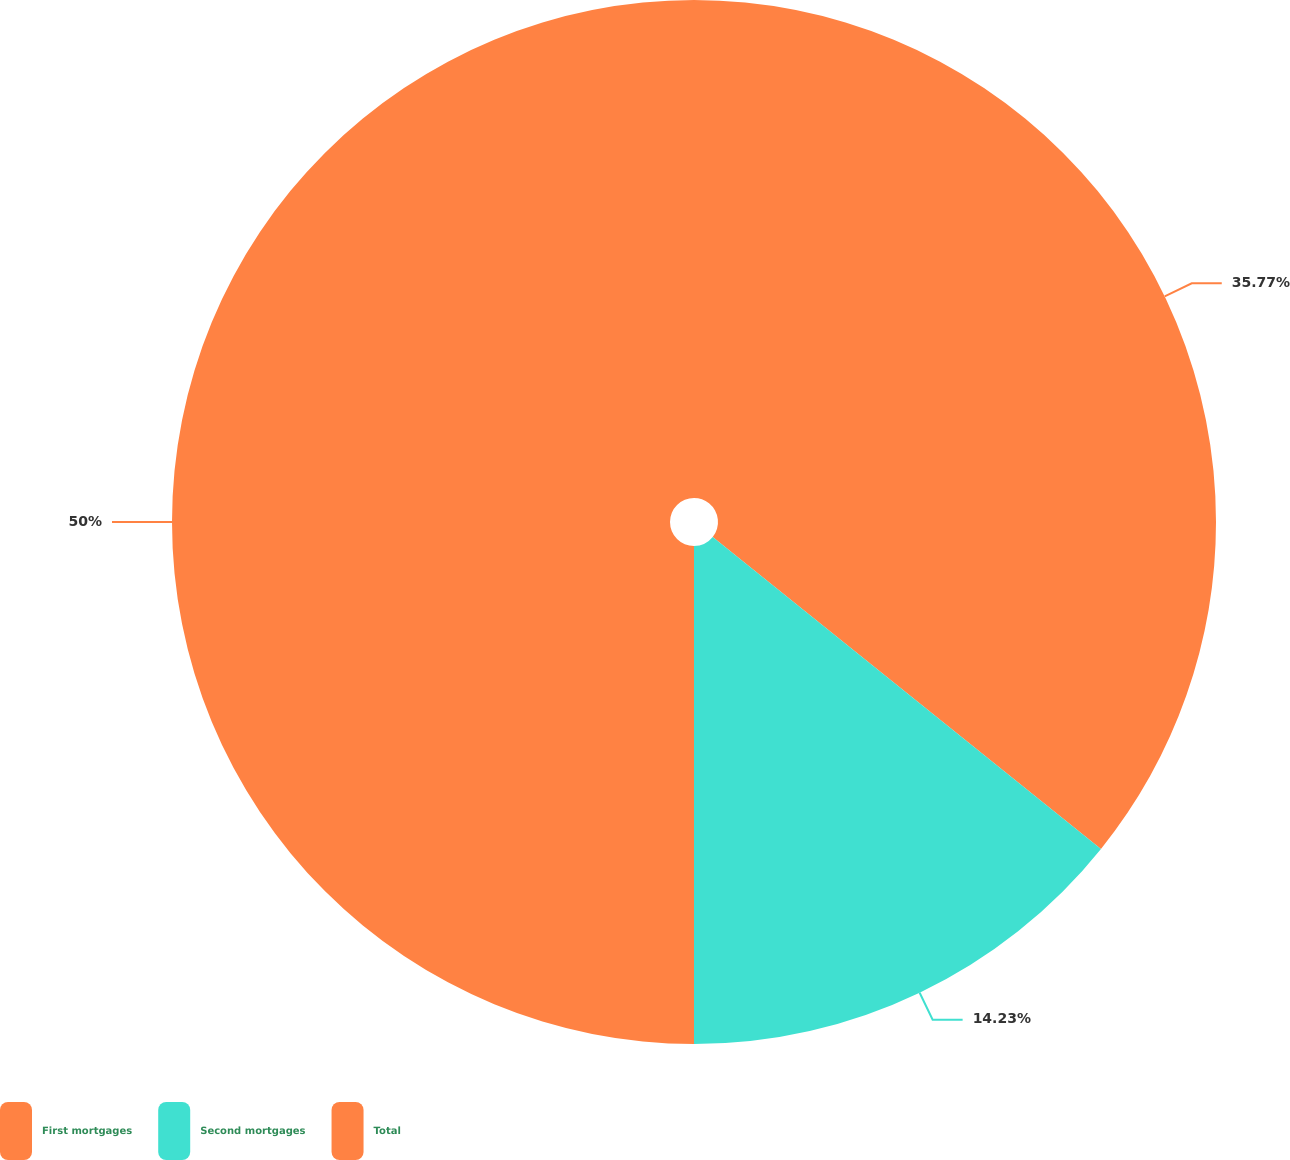<chart> <loc_0><loc_0><loc_500><loc_500><pie_chart><fcel>First mortgages<fcel>Second mortgages<fcel>Total<nl><fcel>35.77%<fcel>14.23%<fcel>50.0%<nl></chart> 